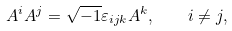Convert formula to latex. <formula><loc_0><loc_0><loc_500><loc_500>A ^ { i } A ^ { j } = \sqrt { - 1 } \varepsilon _ { i j k } A ^ { k } , \quad i \neq j ,</formula> 